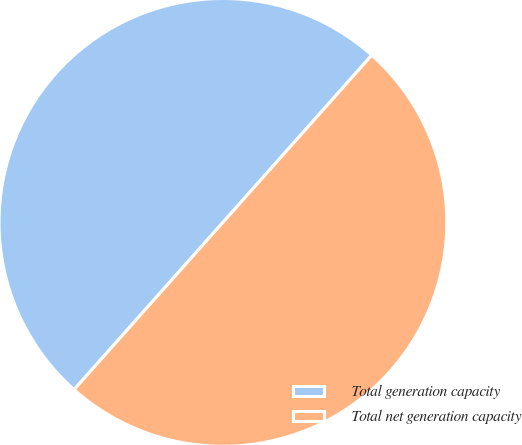<chart> <loc_0><loc_0><loc_500><loc_500><pie_chart><fcel>Total generation capacity<fcel>Total net generation capacity<nl><fcel>50.0%<fcel>50.0%<nl></chart> 